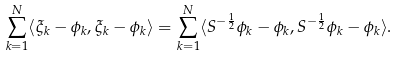Convert formula to latex. <formula><loc_0><loc_0><loc_500><loc_500>\sum _ { k = 1 } ^ { N } \langle \xi _ { k } - \phi _ { k } , \xi _ { k } - \phi _ { k } \rangle = \sum _ { k = 1 } ^ { N } \langle S ^ { - \frac { 1 } { 2 } } \phi _ { k } - \phi _ { k } , S ^ { - \frac { 1 } { 2 } } \phi _ { k } - \phi _ { k } \rangle .</formula> 